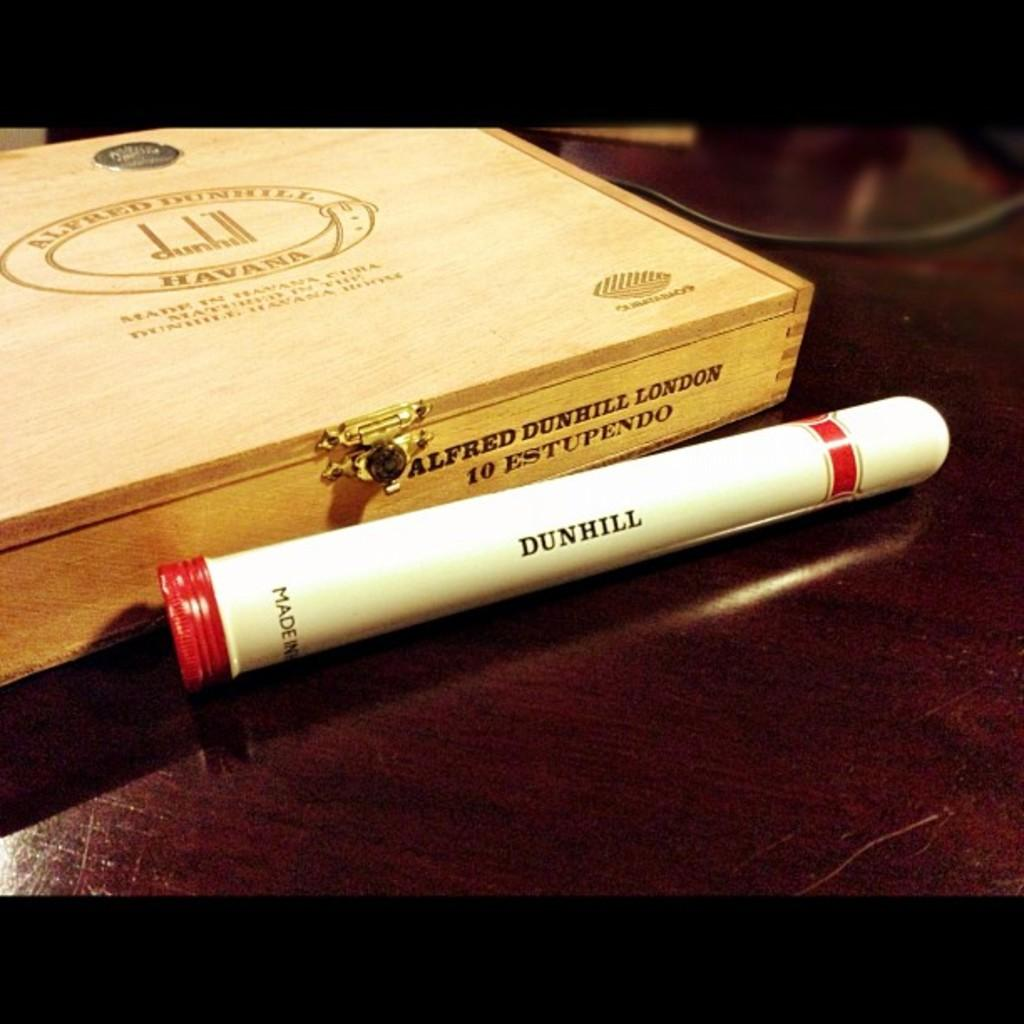<image>
Render a clear and concise summary of the photo. A wooden cigar case that says Alfred Dunhill London. 